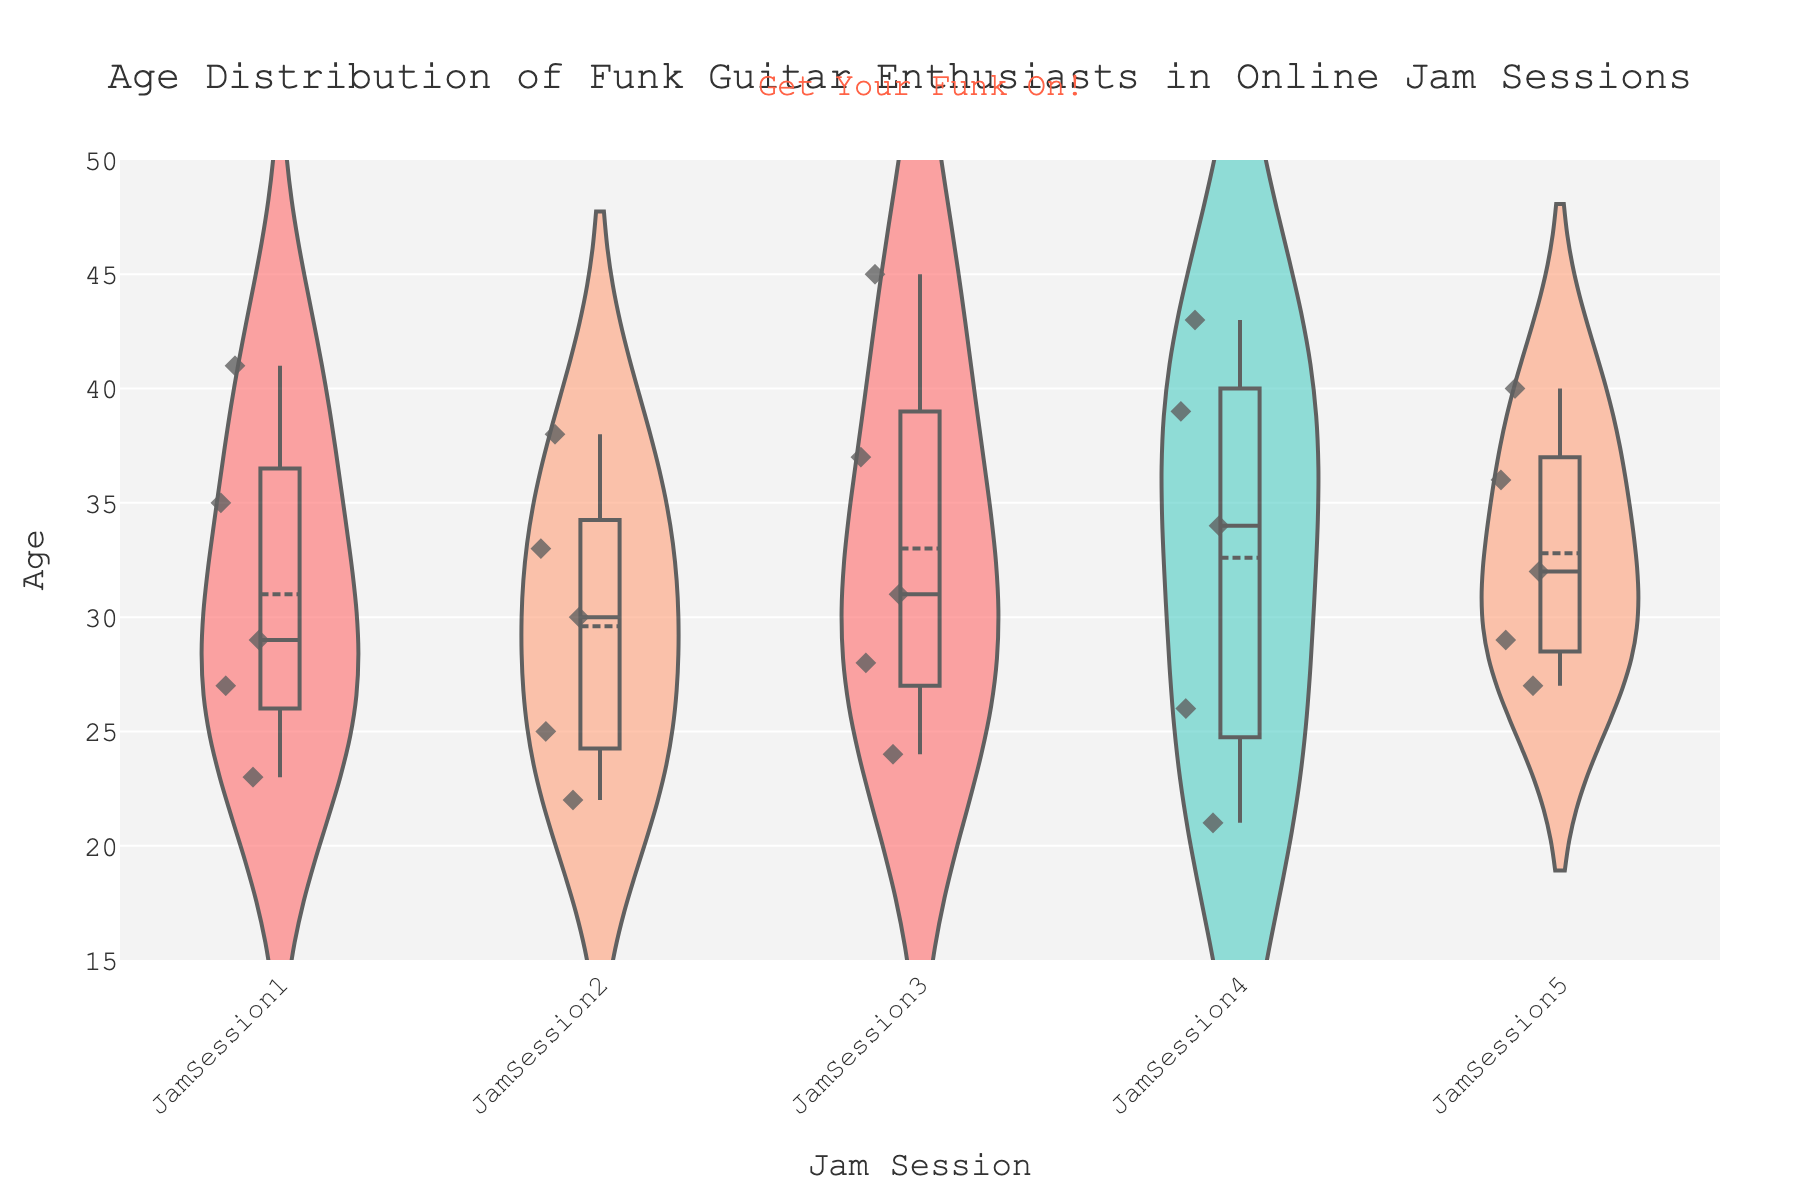What is the title of the plot? The title is displayed at the top of the figure. It reads, "Age Distribution of Funk Guitar Enthusiasts in Online Jam Sessions."
Answer: "Age Distribution of Funk Guitar Enthusiasts in Online Jam Sessions" Which Jam Session has the widest age distribution? By evaluating the spread of the violins, we can identify the session with the widest range of ages. JamSession3 has the widest distribution, spanning from 24 to 45 years.
Answer: JamSession3 What is the range of ages for JamSession2? To find the range, observe the highest and lowest points in JamSession2's violin. The ages vary from 22 to 38 years. Subtracting the lowest age from the highest, we get 38 - 22.
Answer: 16 years Compare the median ages of JamSession1 and JamSession4. Which one is higher? The median is indicated by the horizontal line in the box inside each violin. JamSession1 has a median age around 30, while JamSession4 has a median age around 34. Therefore, JamSession4’s median age is higher.
Answer: JamSession4 What is the average age of attendees in JamSession5? The average age is represented by the mean line. For JamSession5, this line is located around 32 years old.
Answer: 32 years Do any of the sessions have outliers? If so, which ones and what are the values? Outliers are the points that lie outside the main violin shape. JamSession3 and JamSession4 have outliers: JamSession3 at 45 (highest) and JamSession4 at 21 (lowest).
Answer: JamSession3 at 45, JamSession4 at 21 Which Jam Session has the youngest attendee? The youngest attendee can be identified at the bottom of the violins. JamSession4 has the youngest attendee at an age of 21.
Answer: JamSession4 What is the average age difference between the oldest and youngest attendees across all sessions? Calculate the difference for each session and find the average: (41-23) for JS1 is 18, (38-22) for JS2 is 16, (45-24) for JS3 is 21, (43-21) for JS4 is 22, and (40-27) for JS5 is 13. The average of these differences is (18+16+21+22+13)/5 = 18.
Answer: 18 years 